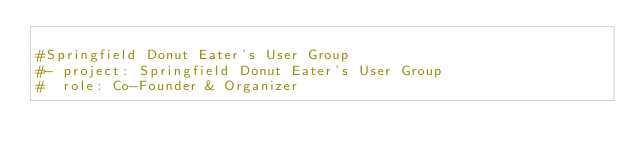<code> <loc_0><loc_0><loc_500><loc_500><_YAML_>
#Springfield Donut Eater's User Group
#- project: Springfield Donut Eater's User Group
#  role: Co-Founder & Organizer</code> 